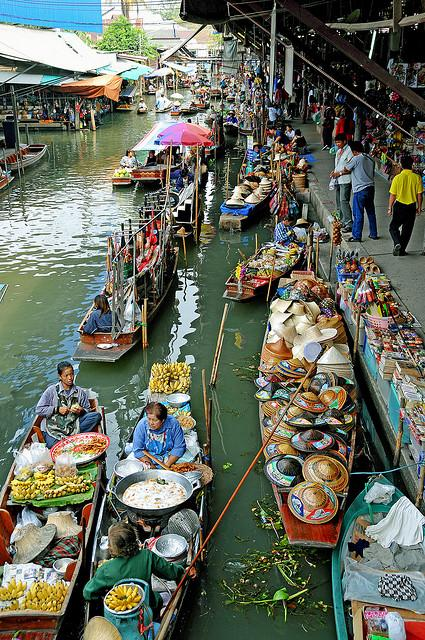What are on some of the boats? Please explain your reasoning. bananas. Some of the boats are carrying yellow fruit. 